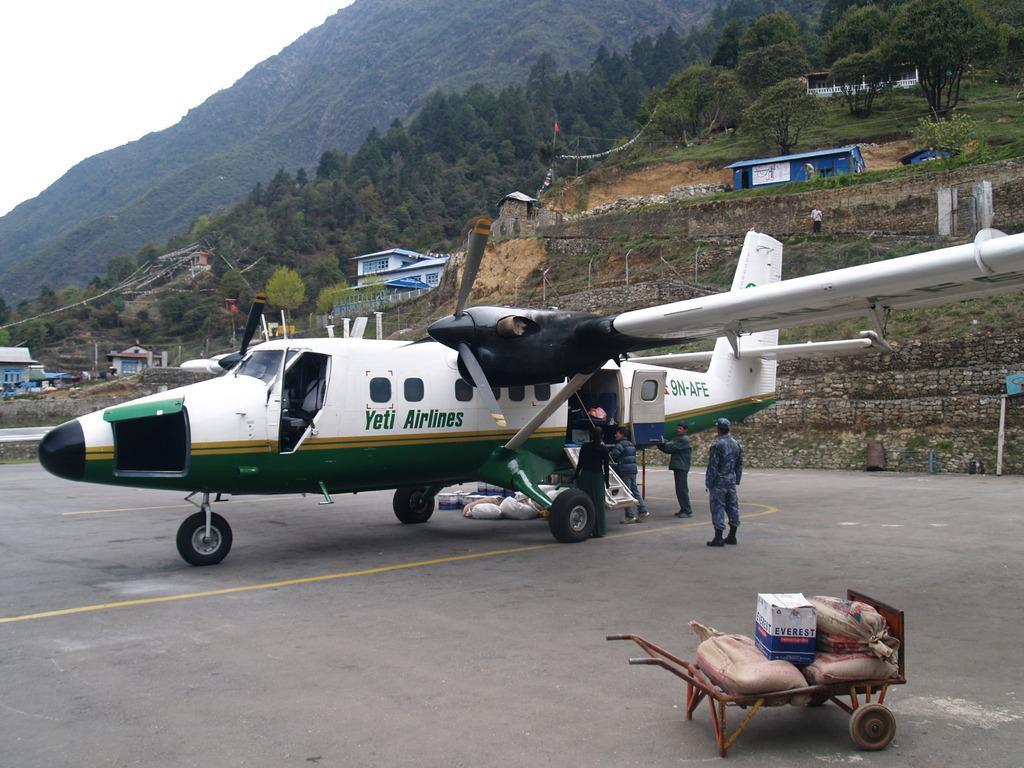Describe this image in one or two sentences. In this image, we can see an aircraft on the road. Here there is a cart with bags and box. Background we can see so many trees, houses, mountain and sky. Here we can see few people. 